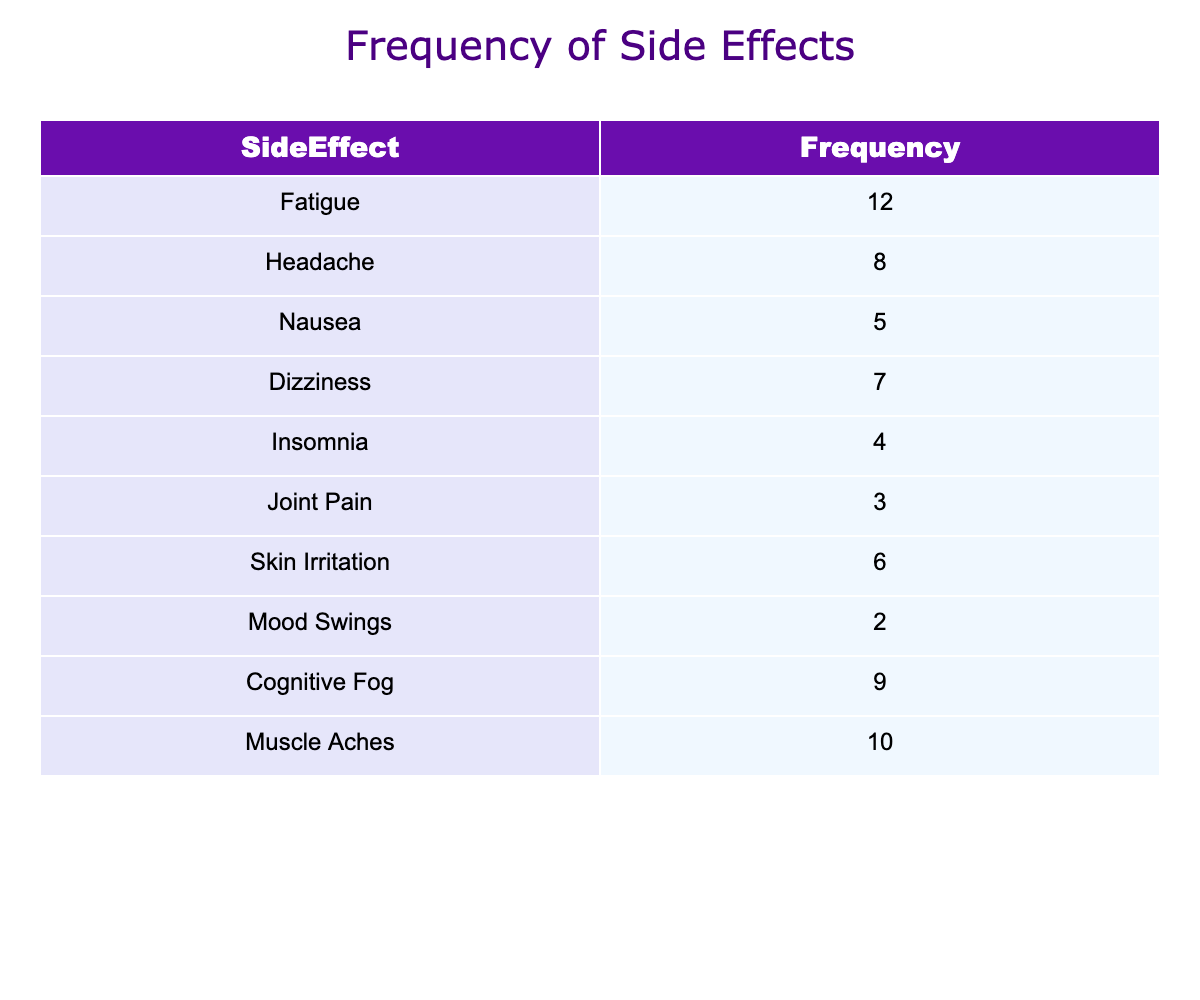What is the most frequently reported side effect? From the table, I look for the maximum frequency value among the side effects. The highest frequency is 12 for Fatigue, which indicates it is the most reported issue among users.
Answer: Fatigue How many users reported experiencing Cognitive Fog? The table clearly lists that 9 users reported experiencing Cognitive Fog. Therefore, the direct answer from the table is 9.
Answer: 9 What is the total number of reported side effects? I add up the frequencies of all the reported side effects: (12 + 8 + 5 + 7 + 4 + 3 + 6 + 2 + 9 + 10) = 66, which shows the total number of side effects reported by users of the device.
Answer: 66 Is Insomnia reported by more users than Joint Pain? According to the table, 4 users reported Insomnia while 3 reported Joint Pain. Since 4 is greater than 3, Insomnia is indeed reported by more users than Joint Pain.
Answer: Yes What is the average number of users reporting a side effect? To calculate the average, I find the total number of reports (66) and divide it by the number of unique side effects (10), resulting in 66 / 10 = 6.6. Therefore, the average number is 6.6.
Answer: 6.6 How many side effects were reported by fewer than 5 users? Reviewing the table, I identify the side effects reported by fewer than 5 users: Joint Pain (3), and Mood Swings (2), which gives me a total of 2 side effects fitting this criterion.
Answer: 2 What side effects have a frequency of 6 or more? I review the frequencies and find the side effects with frequencies of 6 or more are: Fatigue (12), Muscle Aches (10), Cognitive Fog (9), Headache (8), Dizziness (7), and Skin Irritation (6). Hence, there are 6 side effects reported by 6 or more users.
Answer: 6 Which side effect has the lowest frequency? The table shows Mood Swings with a frequency of 2, which is the lowest among all listed side effects, indicating it was reported the least by users.
Answer: Mood Swings What is the difference in frequency between Muscle Aches and Nausea? I locate the frequencies for Muscle Aches (10) and Nausea (5) from the table. The difference is calculated as 10 - 5 = 5, indicating Muscle Aches were reported 5 more times than Nausea.
Answer: 5 